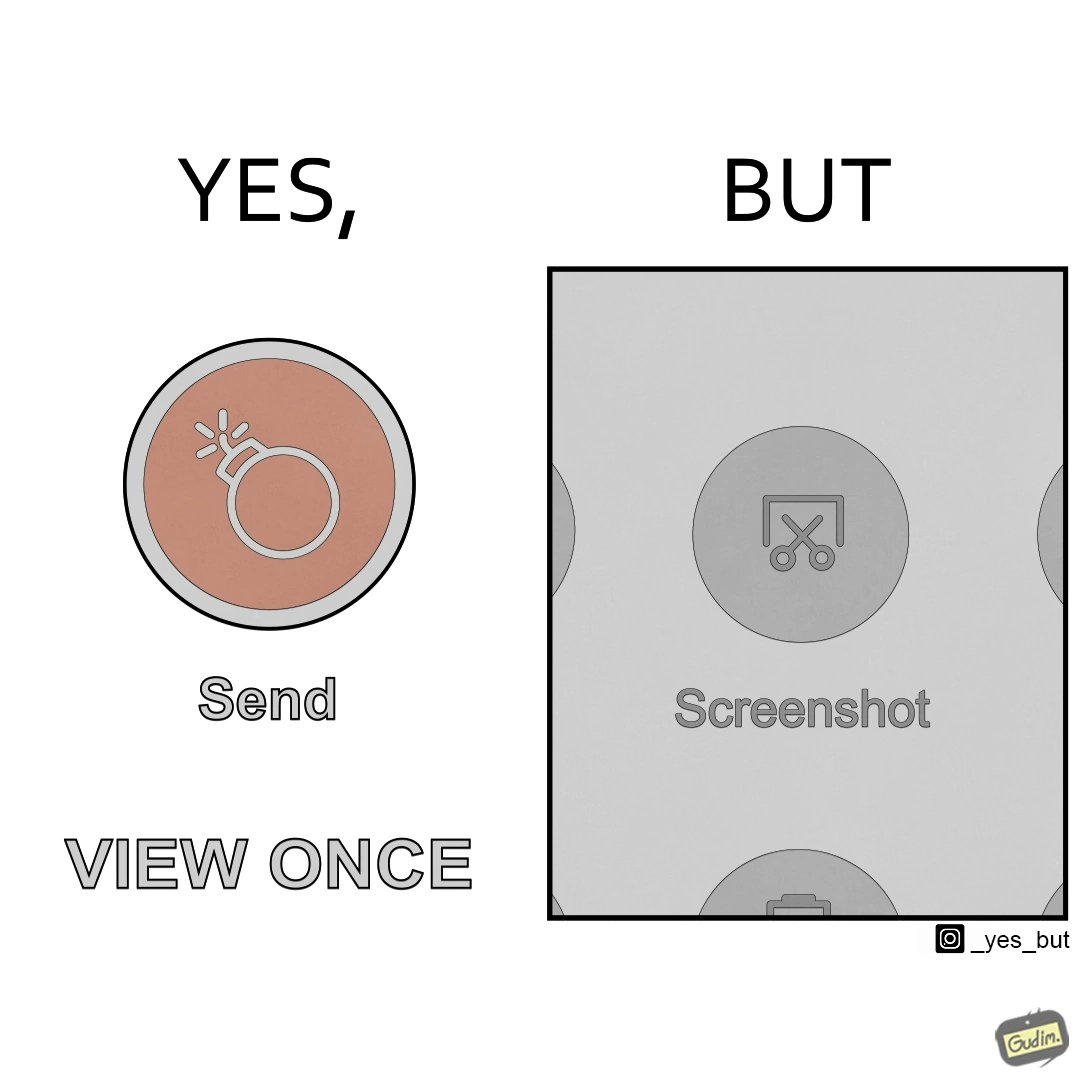Explain the humor or irony in this image. The images are funny since it shows how useless a 'view only once' option is for a sender since the recipient can just take a screenshot of the sent image and view it as many times as he/she wants 